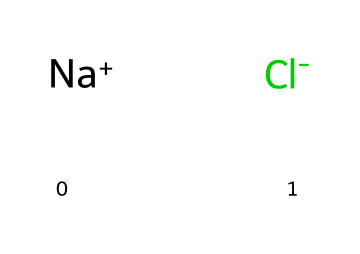what is the chemical name of this compound? The chemical name represented by the SMILES notation [Na+].[Cl-] is sodium chloride, as sodium is denoted by Na and chloride by Cl.
Answer: sodium chloride how many different elements are in this compound? The compound contains two different elements: sodium and chlorine, as indicated by the presence of Na and Cl in the SMILES representation.
Answer: two what are the charges on the ions in this compound? The SMILES notation indicates the presence of sodium as a positive ion (Na+) and chloride as a negative ion (Cl-), clearly showing their respective charges.
Answer: positive and negative what type of compound is sodium chloride? Sodium chloride is classified as an electrolyte because it dissociates into ions (Na+ and Cl-) in solution, which is a characteristic of electrolytic compounds.
Answer: electrolyte how many sodium ions are present in one formula unit of sodium chloride? The structure implies that each formula unit of sodium chloride contains one sodium ion, as indicated by the presence of a single Na+ in the formula.
Answer: one what type of bond exists between sodium and chloride in this compound? The compound sodium chloride features an ionic bond, which occurs between the positively charged sodium ion and the negatively charged chloride ion, resulting from the transfer of an electron.
Answer: ionic bond why is sodium chloride considered essential in sports drinks? Sodium chloride is essential in sports drinks because it provides electrolytes, which help maintain hydration and proper muscle function during physical activities by replenishing lost ions.
Answer: hydration and muscle function 